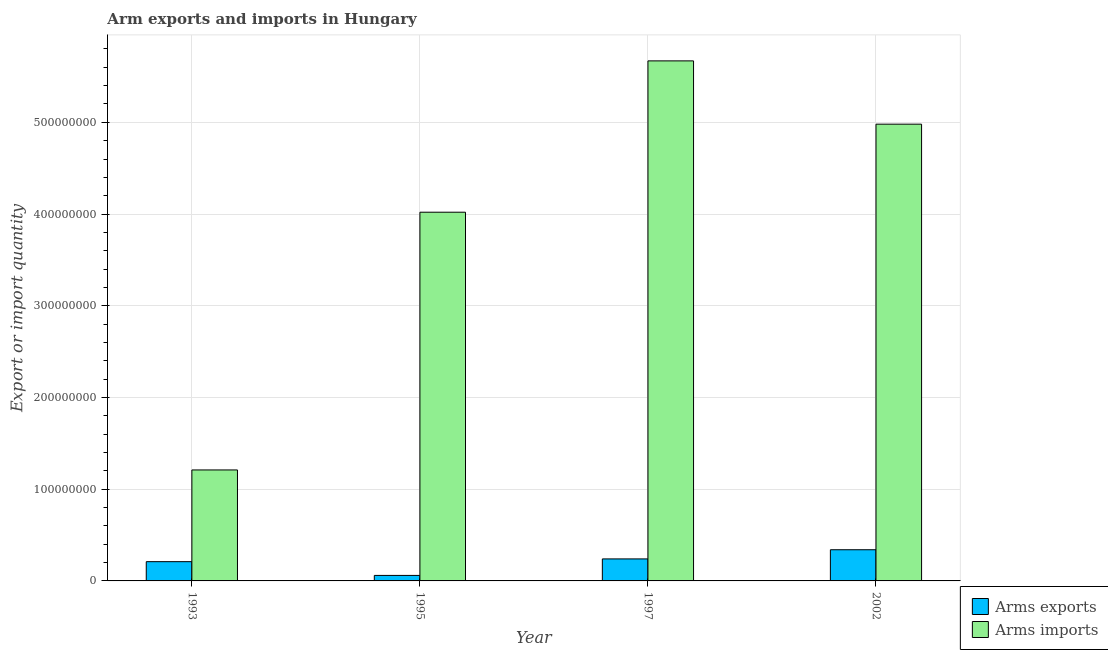How many different coloured bars are there?
Keep it short and to the point. 2. How many bars are there on the 2nd tick from the left?
Offer a terse response. 2. What is the label of the 3rd group of bars from the left?
Provide a short and direct response. 1997. What is the arms imports in 1997?
Make the answer very short. 5.67e+08. Across all years, what is the maximum arms exports?
Offer a terse response. 3.40e+07. Across all years, what is the minimum arms exports?
Provide a succinct answer. 6.00e+06. In which year was the arms imports maximum?
Provide a short and direct response. 1997. In which year was the arms imports minimum?
Provide a short and direct response. 1993. What is the total arms imports in the graph?
Provide a short and direct response. 1.59e+09. What is the difference between the arms exports in 1993 and that in 1997?
Keep it short and to the point. -3.00e+06. What is the difference between the arms imports in 1997 and the arms exports in 1993?
Offer a terse response. 4.46e+08. What is the average arms exports per year?
Your answer should be compact. 2.12e+07. In how many years, is the arms imports greater than 420000000?
Ensure brevity in your answer.  2. What is the ratio of the arms exports in 1995 to that in 2002?
Ensure brevity in your answer.  0.18. Is the arms exports in 1993 less than that in 2002?
Make the answer very short. Yes. Is the difference between the arms exports in 1993 and 1997 greater than the difference between the arms imports in 1993 and 1997?
Your response must be concise. No. What is the difference between the highest and the second highest arms exports?
Your response must be concise. 1.00e+07. What is the difference between the highest and the lowest arms exports?
Offer a terse response. 2.80e+07. Is the sum of the arms exports in 1993 and 1997 greater than the maximum arms imports across all years?
Offer a terse response. Yes. What does the 1st bar from the left in 1995 represents?
Give a very brief answer. Arms exports. What does the 1st bar from the right in 1995 represents?
Provide a short and direct response. Arms imports. How many years are there in the graph?
Make the answer very short. 4. What is the difference between two consecutive major ticks on the Y-axis?
Keep it short and to the point. 1.00e+08. Are the values on the major ticks of Y-axis written in scientific E-notation?
Keep it short and to the point. No. Does the graph contain grids?
Your answer should be compact. Yes. How are the legend labels stacked?
Provide a short and direct response. Vertical. What is the title of the graph?
Offer a very short reply. Arm exports and imports in Hungary. Does "Under-five" appear as one of the legend labels in the graph?
Offer a terse response. No. What is the label or title of the Y-axis?
Your response must be concise. Export or import quantity. What is the Export or import quantity in Arms exports in 1993?
Give a very brief answer. 2.10e+07. What is the Export or import quantity of Arms imports in 1993?
Give a very brief answer. 1.21e+08. What is the Export or import quantity of Arms imports in 1995?
Provide a short and direct response. 4.02e+08. What is the Export or import quantity of Arms exports in 1997?
Provide a succinct answer. 2.40e+07. What is the Export or import quantity of Arms imports in 1997?
Ensure brevity in your answer.  5.67e+08. What is the Export or import quantity in Arms exports in 2002?
Your answer should be compact. 3.40e+07. What is the Export or import quantity of Arms imports in 2002?
Keep it short and to the point. 4.98e+08. Across all years, what is the maximum Export or import quantity of Arms exports?
Make the answer very short. 3.40e+07. Across all years, what is the maximum Export or import quantity in Arms imports?
Make the answer very short. 5.67e+08. Across all years, what is the minimum Export or import quantity of Arms imports?
Offer a very short reply. 1.21e+08. What is the total Export or import quantity in Arms exports in the graph?
Offer a very short reply. 8.50e+07. What is the total Export or import quantity of Arms imports in the graph?
Your answer should be compact. 1.59e+09. What is the difference between the Export or import quantity of Arms exports in 1993 and that in 1995?
Give a very brief answer. 1.50e+07. What is the difference between the Export or import quantity of Arms imports in 1993 and that in 1995?
Offer a terse response. -2.81e+08. What is the difference between the Export or import quantity of Arms exports in 1993 and that in 1997?
Offer a very short reply. -3.00e+06. What is the difference between the Export or import quantity in Arms imports in 1993 and that in 1997?
Your answer should be very brief. -4.46e+08. What is the difference between the Export or import quantity in Arms exports in 1993 and that in 2002?
Your response must be concise. -1.30e+07. What is the difference between the Export or import quantity in Arms imports in 1993 and that in 2002?
Your answer should be compact. -3.77e+08. What is the difference between the Export or import quantity of Arms exports in 1995 and that in 1997?
Provide a succinct answer. -1.80e+07. What is the difference between the Export or import quantity of Arms imports in 1995 and that in 1997?
Provide a succinct answer. -1.65e+08. What is the difference between the Export or import quantity of Arms exports in 1995 and that in 2002?
Keep it short and to the point. -2.80e+07. What is the difference between the Export or import quantity of Arms imports in 1995 and that in 2002?
Give a very brief answer. -9.60e+07. What is the difference between the Export or import quantity in Arms exports in 1997 and that in 2002?
Give a very brief answer. -1.00e+07. What is the difference between the Export or import quantity in Arms imports in 1997 and that in 2002?
Provide a succinct answer. 6.90e+07. What is the difference between the Export or import quantity in Arms exports in 1993 and the Export or import quantity in Arms imports in 1995?
Offer a very short reply. -3.81e+08. What is the difference between the Export or import quantity of Arms exports in 1993 and the Export or import quantity of Arms imports in 1997?
Your answer should be compact. -5.46e+08. What is the difference between the Export or import quantity in Arms exports in 1993 and the Export or import quantity in Arms imports in 2002?
Your answer should be compact. -4.77e+08. What is the difference between the Export or import quantity of Arms exports in 1995 and the Export or import quantity of Arms imports in 1997?
Provide a short and direct response. -5.61e+08. What is the difference between the Export or import quantity of Arms exports in 1995 and the Export or import quantity of Arms imports in 2002?
Give a very brief answer. -4.92e+08. What is the difference between the Export or import quantity of Arms exports in 1997 and the Export or import quantity of Arms imports in 2002?
Make the answer very short. -4.74e+08. What is the average Export or import quantity of Arms exports per year?
Give a very brief answer. 2.12e+07. What is the average Export or import quantity in Arms imports per year?
Offer a terse response. 3.97e+08. In the year 1993, what is the difference between the Export or import quantity of Arms exports and Export or import quantity of Arms imports?
Keep it short and to the point. -1.00e+08. In the year 1995, what is the difference between the Export or import quantity in Arms exports and Export or import quantity in Arms imports?
Ensure brevity in your answer.  -3.96e+08. In the year 1997, what is the difference between the Export or import quantity in Arms exports and Export or import quantity in Arms imports?
Keep it short and to the point. -5.43e+08. In the year 2002, what is the difference between the Export or import quantity in Arms exports and Export or import quantity in Arms imports?
Provide a short and direct response. -4.64e+08. What is the ratio of the Export or import quantity in Arms exports in 1993 to that in 1995?
Ensure brevity in your answer.  3.5. What is the ratio of the Export or import quantity of Arms imports in 1993 to that in 1995?
Make the answer very short. 0.3. What is the ratio of the Export or import quantity of Arms imports in 1993 to that in 1997?
Provide a short and direct response. 0.21. What is the ratio of the Export or import quantity of Arms exports in 1993 to that in 2002?
Make the answer very short. 0.62. What is the ratio of the Export or import quantity of Arms imports in 1993 to that in 2002?
Give a very brief answer. 0.24. What is the ratio of the Export or import quantity in Arms exports in 1995 to that in 1997?
Keep it short and to the point. 0.25. What is the ratio of the Export or import quantity in Arms imports in 1995 to that in 1997?
Offer a terse response. 0.71. What is the ratio of the Export or import quantity of Arms exports in 1995 to that in 2002?
Keep it short and to the point. 0.18. What is the ratio of the Export or import quantity of Arms imports in 1995 to that in 2002?
Offer a terse response. 0.81. What is the ratio of the Export or import quantity in Arms exports in 1997 to that in 2002?
Offer a very short reply. 0.71. What is the ratio of the Export or import quantity of Arms imports in 1997 to that in 2002?
Give a very brief answer. 1.14. What is the difference between the highest and the second highest Export or import quantity of Arms imports?
Offer a terse response. 6.90e+07. What is the difference between the highest and the lowest Export or import quantity of Arms exports?
Ensure brevity in your answer.  2.80e+07. What is the difference between the highest and the lowest Export or import quantity in Arms imports?
Provide a short and direct response. 4.46e+08. 